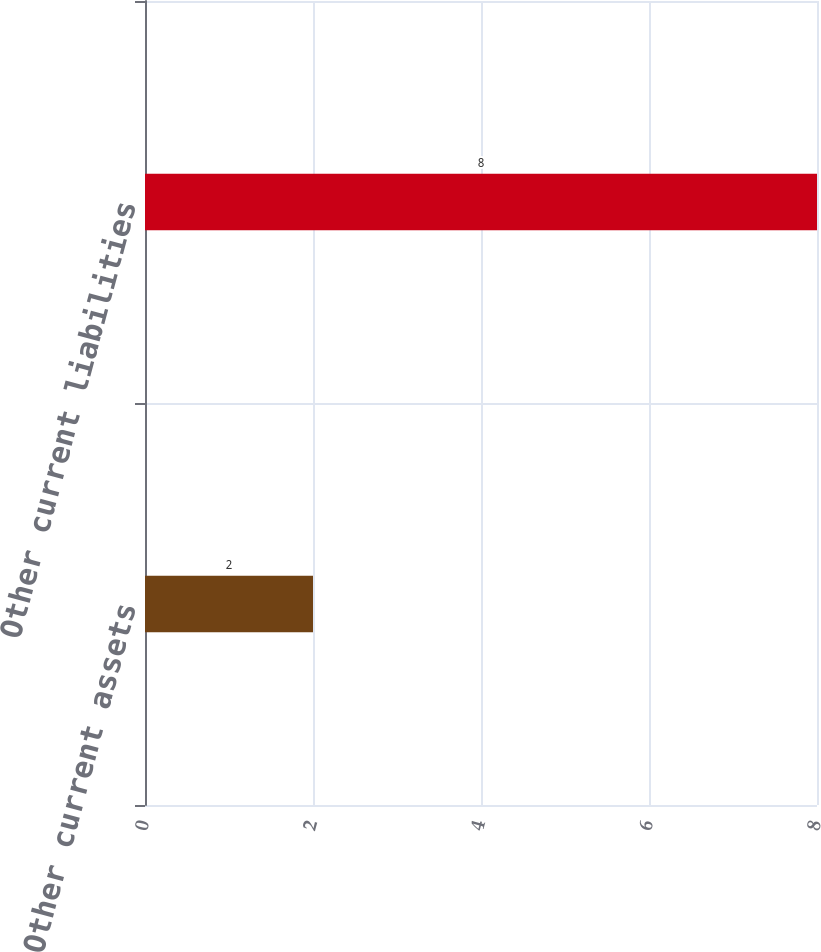Convert chart. <chart><loc_0><loc_0><loc_500><loc_500><bar_chart><fcel>Other current assets<fcel>Other current liabilities<nl><fcel>2<fcel>8<nl></chart> 